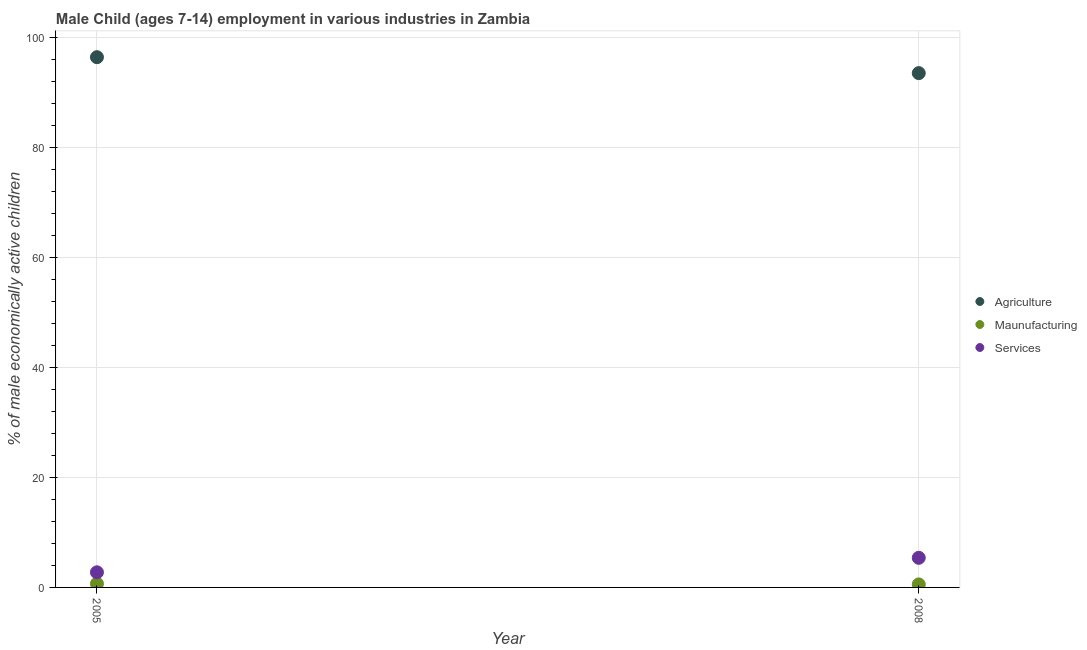Is the number of dotlines equal to the number of legend labels?
Ensure brevity in your answer.  Yes. What is the percentage of economically active children in manufacturing in 2008?
Provide a short and direct response. 0.55. Across all years, what is the maximum percentage of economically active children in services?
Offer a terse response. 5.39. Across all years, what is the minimum percentage of economically active children in services?
Ensure brevity in your answer.  2.75. In which year was the percentage of economically active children in manufacturing minimum?
Provide a succinct answer. 2008. What is the total percentage of economically active children in agriculture in the graph?
Your answer should be very brief. 190.04. What is the difference between the percentage of economically active children in agriculture in 2005 and that in 2008?
Your response must be concise. 2.9. What is the difference between the percentage of economically active children in agriculture in 2005 and the percentage of economically active children in services in 2008?
Make the answer very short. 91.08. What is the average percentage of economically active children in services per year?
Give a very brief answer. 4.07. In the year 2005, what is the difference between the percentage of economically active children in services and percentage of economically active children in manufacturing?
Make the answer very short. 2.07. What is the ratio of the percentage of economically active children in agriculture in 2005 to that in 2008?
Your answer should be very brief. 1.03. Is the percentage of economically active children in manufacturing in 2005 less than that in 2008?
Make the answer very short. No. In how many years, is the percentage of economically active children in manufacturing greater than the average percentage of economically active children in manufacturing taken over all years?
Your answer should be very brief. 1. Is it the case that in every year, the sum of the percentage of economically active children in agriculture and percentage of economically active children in manufacturing is greater than the percentage of economically active children in services?
Your answer should be compact. Yes. Does the graph contain any zero values?
Provide a succinct answer. No. How are the legend labels stacked?
Provide a succinct answer. Vertical. What is the title of the graph?
Give a very brief answer. Male Child (ages 7-14) employment in various industries in Zambia. What is the label or title of the Y-axis?
Keep it short and to the point. % of male economically active children. What is the % of male economically active children of Agriculture in 2005?
Make the answer very short. 96.47. What is the % of male economically active children of Maunufacturing in 2005?
Your response must be concise. 0.68. What is the % of male economically active children in Services in 2005?
Keep it short and to the point. 2.75. What is the % of male economically active children in Agriculture in 2008?
Give a very brief answer. 93.57. What is the % of male economically active children in Maunufacturing in 2008?
Provide a short and direct response. 0.55. What is the % of male economically active children of Services in 2008?
Ensure brevity in your answer.  5.39. Across all years, what is the maximum % of male economically active children in Agriculture?
Provide a succinct answer. 96.47. Across all years, what is the maximum % of male economically active children in Maunufacturing?
Give a very brief answer. 0.68. Across all years, what is the maximum % of male economically active children in Services?
Offer a very short reply. 5.39. Across all years, what is the minimum % of male economically active children in Agriculture?
Provide a succinct answer. 93.57. Across all years, what is the minimum % of male economically active children in Maunufacturing?
Offer a very short reply. 0.55. Across all years, what is the minimum % of male economically active children of Services?
Give a very brief answer. 2.75. What is the total % of male economically active children in Agriculture in the graph?
Offer a very short reply. 190.04. What is the total % of male economically active children of Maunufacturing in the graph?
Give a very brief answer. 1.23. What is the total % of male economically active children of Services in the graph?
Provide a succinct answer. 8.14. What is the difference between the % of male economically active children of Agriculture in 2005 and that in 2008?
Your answer should be compact. 2.9. What is the difference between the % of male economically active children of Maunufacturing in 2005 and that in 2008?
Offer a very short reply. 0.13. What is the difference between the % of male economically active children of Services in 2005 and that in 2008?
Your answer should be very brief. -2.64. What is the difference between the % of male economically active children of Agriculture in 2005 and the % of male economically active children of Maunufacturing in 2008?
Your response must be concise. 95.92. What is the difference between the % of male economically active children of Agriculture in 2005 and the % of male economically active children of Services in 2008?
Provide a short and direct response. 91.08. What is the difference between the % of male economically active children of Maunufacturing in 2005 and the % of male economically active children of Services in 2008?
Offer a very short reply. -4.71. What is the average % of male economically active children of Agriculture per year?
Your answer should be compact. 95.02. What is the average % of male economically active children in Maunufacturing per year?
Offer a terse response. 0.61. What is the average % of male economically active children of Services per year?
Ensure brevity in your answer.  4.07. In the year 2005, what is the difference between the % of male economically active children of Agriculture and % of male economically active children of Maunufacturing?
Keep it short and to the point. 95.79. In the year 2005, what is the difference between the % of male economically active children of Agriculture and % of male economically active children of Services?
Offer a terse response. 93.72. In the year 2005, what is the difference between the % of male economically active children of Maunufacturing and % of male economically active children of Services?
Offer a very short reply. -2.07. In the year 2008, what is the difference between the % of male economically active children of Agriculture and % of male economically active children of Maunufacturing?
Your response must be concise. 93.02. In the year 2008, what is the difference between the % of male economically active children in Agriculture and % of male economically active children in Services?
Provide a succinct answer. 88.18. In the year 2008, what is the difference between the % of male economically active children in Maunufacturing and % of male economically active children in Services?
Give a very brief answer. -4.84. What is the ratio of the % of male economically active children of Agriculture in 2005 to that in 2008?
Offer a terse response. 1.03. What is the ratio of the % of male economically active children in Maunufacturing in 2005 to that in 2008?
Give a very brief answer. 1.24. What is the ratio of the % of male economically active children of Services in 2005 to that in 2008?
Offer a very short reply. 0.51. What is the difference between the highest and the second highest % of male economically active children in Agriculture?
Your answer should be very brief. 2.9. What is the difference between the highest and the second highest % of male economically active children of Maunufacturing?
Provide a short and direct response. 0.13. What is the difference between the highest and the second highest % of male economically active children in Services?
Make the answer very short. 2.64. What is the difference between the highest and the lowest % of male economically active children of Agriculture?
Provide a succinct answer. 2.9. What is the difference between the highest and the lowest % of male economically active children of Maunufacturing?
Offer a terse response. 0.13. What is the difference between the highest and the lowest % of male economically active children of Services?
Make the answer very short. 2.64. 